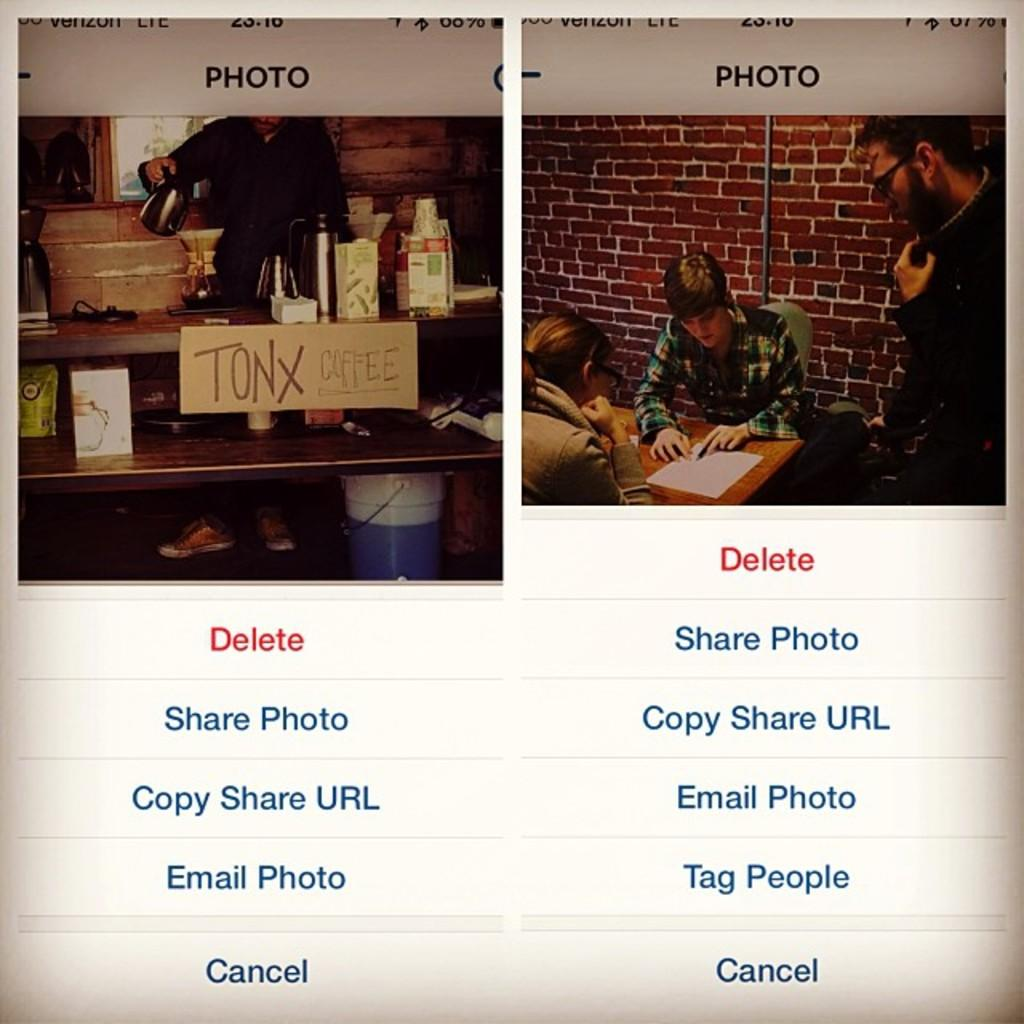<image>
Create a compact narrative representing the image presented. Close up of a cell phone screen showing some young people studying at a table and a shot of a sign that reads Tonx Coffee. 